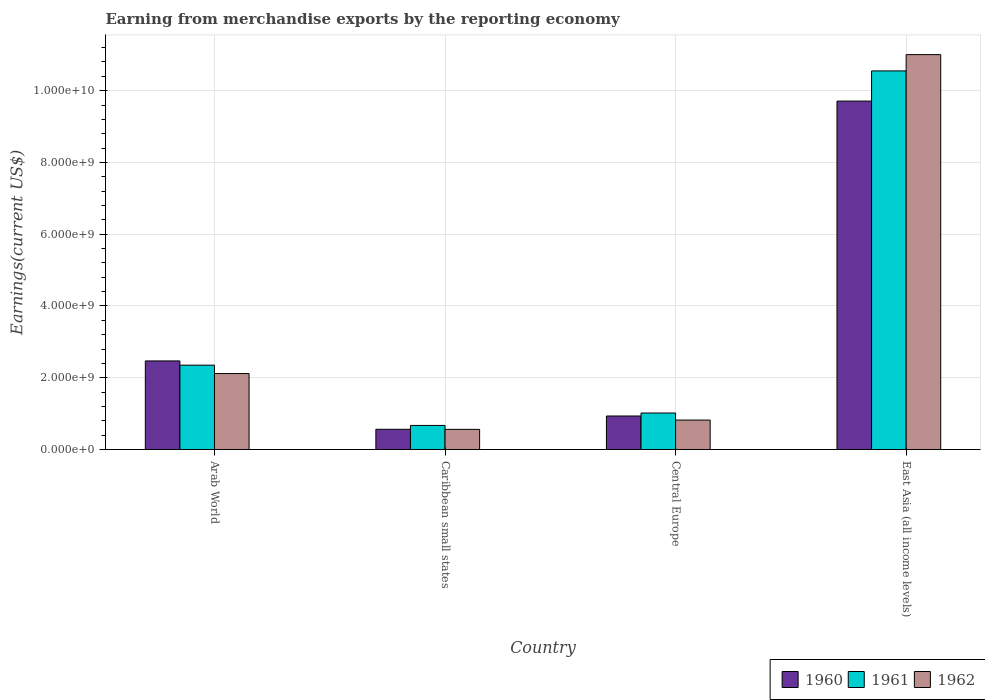How many different coloured bars are there?
Give a very brief answer. 3. How many groups of bars are there?
Provide a short and direct response. 4. Are the number of bars on each tick of the X-axis equal?
Ensure brevity in your answer.  Yes. What is the label of the 2nd group of bars from the left?
Make the answer very short. Caribbean small states. In how many cases, is the number of bars for a given country not equal to the number of legend labels?
Offer a terse response. 0. What is the amount earned from merchandise exports in 1962 in East Asia (all income levels)?
Your answer should be very brief. 1.10e+1. Across all countries, what is the maximum amount earned from merchandise exports in 1961?
Provide a succinct answer. 1.06e+1. Across all countries, what is the minimum amount earned from merchandise exports in 1961?
Offer a terse response. 6.71e+08. In which country was the amount earned from merchandise exports in 1962 maximum?
Your response must be concise. East Asia (all income levels). In which country was the amount earned from merchandise exports in 1960 minimum?
Provide a short and direct response. Caribbean small states. What is the total amount earned from merchandise exports in 1960 in the graph?
Provide a short and direct response. 1.37e+1. What is the difference between the amount earned from merchandise exports in 1962 in Arab World and that in East Asia (all income levels)?
Offer a very short reply. -8.89e+09. What is the difference between the amount earned from merchandise exports in 1962 in Caribbean small states and the amount earned from merchandise exports in 1960 in East Asia (all income levels)?
Your answer should be very brief. -9.15e+09. What is the average amount earned from merchandise exports in 1960 per country?
Provide a short and direct response. 3.42e+09. What is the difference between the amount earned from merchandise exports of/in 1961 and amount earned from merchandise exports of/in 1960 in Arab World?
Your response must be concise. -1.18e+08. What is the ratio of the amount earned from merchandise exports in 1960 in Central Europe to that in East Asia (all income levels)?
Provide a short and direct response. 0.1. Is the amount earned from merchandise exports in 1960 in Caribbean small states less than that in East Asia (all income levels)?
Offer a terse response. Yes. Is the difference between the amount earned from merchandise exports in 1961 in Arab World and Central Europe greater than the difference between the amount earned from merchandise exports in 1960 in Arab World and Central Europe?
Give a very brief answer. No. What is the difference between the highest and the second highest amount earned from merchandise exports in 1962?
Provide a succinct answer. 1.02e+1. What is the difference between the highest and the lowest amount earned from merchandise exports in 1962?
Keep it short and to the point. 1.04e+1. What does the 2nd bar from the left in Caribbean small states represents?
Your answer should be very brief. 1961. What does the 3rd bar from the right in Arab World represents?
Provide a succinct answer. 1960. Is it the case that in every country, the sum of the amount earned from merchandise exports in 1962 and amount earned from merchandise exports in 1961 is greater than the amount earned from merchandise exports in 1960?
Give a very brief answer. Yes. How many bars are there?
Your answer should be compact. 12. Are all the bars in the graph horizontal?
Provide a succinct answer. No. Are the values on the major ticks of Y-axis written in scientific E-notation?
Your answer should be very brief. Yes. Does the graph contain any zero values?
Give a very brief answer. No. Does the graph contain grids?
Ensure brevity in your answer.  Yes. Where does the legend appear in the graph?
Make the answer very short. Bottom right. How many legend labels are there?
Your answer should be very brief. 3. What is the title of the graph?
Make the answer very short. Earning from merchandise exports by the reporting economy. What is the label or title of the Y-axis?
Your response must be concise. Earnings(current US$). What is the Earnings(current US$) of 1960 in Arab World?
Provide a short and direct response. 2.47e+09. What is the Earnings(current US$) in 1961 in Arab World?
Offer a terse response. 2.35e+09. What is the Earnings(current US$) in 1962 in Arab World?
Your answer should be compact. 2.12e+09. What is the Earnings(current US$) in 1960 in Caribbean small states?
Provide a short and direct response. 5.64e+08. What is the Earnings(current US$) of 1961 in Caribbean small states?
Give a very brief answer. 6.71e+08. What is the Earnings(current US$) in 1962 in Caribbean small states?
Offer a very short reply. 5.62e+08. What is the Earnings(current US$) of 1960 in Central Europe?
Keep it short and to the point. 9.34e+08. What is the Earnings(current US$) in 1961 in Central Europe?
Offer a terse response. 1.02e+09. What is the Earnings(current US$) of 1962 in Central Europe?
Your answer should be very brief. 8.21e+08. What is the Earnings(current US$) of 1960 in East Asia (all income levels)?
Give a very brief answer. 9.71e+09. What is the Earnings(current US$) in 1961 in East Asia (all income levels)?
Make the answer very short. 1.06e+1. What is the Earnings(current US$) in 1962 in East Asia (all income levels)?
Keep it short and to the point. 1.10e+1. Across all countries, what is the maximum Earnings(current US$) of 1960?
Offer a terse response. 9.71e+09. Across all countries, what is the maximum Earnings(current US$) in 1961?
Keep it short and to the point. 1.06e+1. Across all countries, what is the maximum Earnings(current US$) in 1962?
Offer a very short reply. 1.10e+1. Across all countries, what is the minimum Earnings(current US$) of 1960?
Ensure brevity in your answer.  5.64e+08. Across all countries, what is the minimum Earnings(current US$) of 1961?
Your answer should be compact. 6.71e+08. Across all countries, what is the minimum Earnings(current US$) of 1962?
Keep it short and to the point. 5.62e+08. What is the total Earnings(current US$) of 1960 in the graph?
Keep it short and to the point. 1.37e+1. What is the total Earnings(current US$) of 1961 in the graph?
Keep it short and to the point. 1.46e+1. What is the total Earnings(current US$) in 1962 in the graph?
Provide a short and direct response. 1.45e+1. What is the difference between the Earnings(current US$) of 1960 in Arab World and that in Caribbean small states?
Provide a succinct answer. 1.90e+09. What is the difference between the Earnings(current US$) of 1961 in Arab World and that in Caribbean small states?
Ensure brevity in your answer.  1.68e+09. What is the difference between the Earnings(current US$) of 1962 in Arab World and that in Caribbean small states?
Ensure brevity in your answer.  1.56e+09. What is the difference between the Earnings(current US$) of 1960 in Arab World and that in Central Europe?
Ensure brevity in your answer.  1.53e+09. What is the difference between the Earnings(current US$) in 1961 in Arab World and that in Central Europe?
Give a very brief answer. 1.33e+09. What is the difference between the Earnings(current US$) of 1962 in Arab World and that in Central Europe?
Your answer should be very brief. 1.30e+09. What is the difference between the Earnings(current US$) of 1960 in Arab World and that in East Asia (all income levels)?
Give a very brief answer. -7.24e+09. What is the difference between the Earnings(current US$) in 1961 in Arab World and that in East Asia (all income levels)?
Offer a terse response. -8.20e+09. What is the difference between the Earnings(current US$) in 1962 in Arab World and that in East Asia (all income levels)?
Ensure brevity in your answer.  -8.89e+09. What is the difference between the Earnings(current US$) in 1960 in Caribbean small states and that in Central Europe?
Provide a succinct answer. -3.70e+08. What is the difference between the Earnings(current US$) in 1961 in Caribbean small states and that in Central Europe?
Your answer should be very brief. -3.46e+08. What is the difference between the Earnings(current US$) in 1962 in Caribbean small states and that in Central Europe?
Provide a short and direct response. -2.60e+08. What is the difference between the Earnings(current US$) in 1960 in Caribbean small states and that in East Asia (all income levels)?
Provide a succinct answer. -9.15e+09. What is the difference between the Earnings(current US$) of 1961 in Caribbean small states and that in East Asia (all income levels)?
Your answer should be very brief. -9.88e+09. What is the difference between the Earnings(current US$) in 1962 in Caribbean small states and that in East Asia (all income levels)?
Ensure brevity in your answer.  -1.04e+1. What is the difference between the Earnings(current US$) in 1960 in Central Europe and that in East Asia (all income levels)?
Provide a succinct answer. -8.78e+09. What is the difference between the Earnings(current US$) in 1961 in Central Europe and that in East Asia (all income levels)?
Keep it short and to the point. -9.53e+09. What is the difference between the Earnings(current US$) in 1962 in Central Europe and that in East Asia (all income levels)?
Provide a succinct answer. -1.02e+1. What is the difference between the Earnings(current US$) of 1960 in Arab World and the Earnings(current US$) of 1961 in Caribbean small states?
Offer a terse response. 1.80e+09. What is the difference between the Earnings(current US$) in 1960 in Arab World and the Earnings(current US$) in 1962 in Caribbean small states?
Provide a short and direct response. 1.91e+09. What is the difference between the Earnings(current US$) in 1961 in Arab World and the Earnings(current US$) in 1962 in Caribbean small states?
Your answer should be compact. 1.79e+09. What is the difference between the Earnings(current US$) in 1960 in Arab World and the Earnings(current US$) in 1961 in Central Europe?
Keep it short and to the point. 1.45e+09. What is the difference between the Earnings(current US$) of 1960 in Arab World and the Earnings(current US$) of 1962 in Central Europe?
Offer a terse response. 1.65e+09. What is the difference between the Earnings(current US$) in 1961 in Arab World and the Earnings(current US$) in 1962 in Central Europe?
Keep it short and to the point. 1.53e+09. What is the difference between the Earnings(current US$) in 1960 in Arab World and the Earnings(current US$) in 1961 in East Asia (all income levels)?
Provide a short and direct response. -8.08e+09. What is the difference between the Earnings(current US$) in 1960 in Arab World and the Earnings(current US$) in 1962 in East Asia (all income levels)?
Your response must be concise. -8.54e+09. What is the difference between the Earnings(current US$) of 1961 in Arab World and the Earnings(current US$) of 1962 in East Asia (all income levels)?
Your answer should be very brief. -8.65e+09. What is the difference between the Earnings(current US$) of 1960 in Caribbean small states and the Earnings(current US$) of 1961 in Central Europe?
Provide a short and direct response. -4.53e+08. What is the difference between the Earnings(current US$) in 1960 in Caribbean small states and the Earnings(current US$) in 1962 in Central Europe?
Give a very brief answer. -2.57e+08. What is the difference between the Earnings(current US$) of 1961 in Caribbean small states and the Earnings(current US$) of 1962 in Central Europe?
Give a very brief answer. -1.50e+08. What is the difference between the Earnings(current US$) of 1960 in Caribbean small states and the Earnings(current US$) of 1961 in East Asia (all income levels)?
Your answer should be compact. -9.99e+09. What is the difference between the Earnings(current US$) in 1960 in Caribbean small states and the Earnings(current US$) in 1962 in East Asia (all income levels)?
Your answer should be compact. -1.04e+1. What is the difference between the Earnings(current US$) of 1961 in Caribbean small states and the Earnings(current US$) of 1962 in East Asia (all income levels)?
Provide a short and direct response. -1.03e+1. What is the difference between the Earnings(current US$) in 1960 in Central Europe and the Earnings(current US$) in 1961 in East Asia (all income levels)?
Provide a short and direct response. -9.62e+09. What is the difference between the Earnings(current US$) in 1960 in Central Europe and the Earnings(current US$) in 1962 in East Asia (all income levels)?
Offer a terse response. -1.01e+1. What is the difference between the Earnings(current US$) in 1961 in Central Europe and the Earnings(current US$) in 1962 in East Asia (all income levels)?
Offer a very short reply. -9.99e+09. What is the average Earnings(current US$) of 1960 per country?
Provide a short and direct response. 3.42e+09. What is the average Earnings(current US$) of 1961 per country?
Make the answer very short. 3.65e+09. What is the average Earnings(current US$) of 1962 per country?
Make the answer very short. 3.63e+09. What is the difference between the Earnings(current US$) in 1960 and Earnings(current US$) in 1961 in Arab World?
Offer a very short reply. 1.18e+08. What is the difference between the Earnings(current US$) of 1960 and Earnings(current US$) of 1962 in Arab World?
Your answer should be compact. 3.52e+08. What is the difference between the Earnings(current US$) in 1961 and Earnings(current US$) in 1962 in Arab World?
Your answer should be compact. 2.34e+08. What is the difference between the Earnings(current US$) in 1960 and Earnings(current US$) in 1961 in Caribbean small states?
Keep it short and to the point. -1.07e+08. What is the difference between the Earnings(current US$) in 1960 and Earnings(current US$) in 1962 in Caribbean small states?
Your answer should be very brief. 2.40e+06. What is the difference between the Earnings(current US$) of 1961 and Earnings(current US$) of 1962 in Caribbean small states?
Provide a short and direct response. 1.10e+08. What is the difference between the Earnings(current US$) in 1960 and Earnings(current US$) in 1961 in Central Europe?
Keep it short and to the point. -8.30e+07. What is the difference between the Earnings(current US$) in 1960 and Earnings(current US$) in 1962 in Central Europe?
Provide a short and direct response. 1.13e+08. What is the difference between the Earnings(current US$) in 1961 and Earnings(current US$) in 1962 in Central Europe?
Keep it short and to the point. 1.96e+08. What is the difference between the Earnings(current US$) of 1960 and Earnings(current US$) of 1961 in East Asia (all income levels)?
Give a very brief answer. -8.41e+08. What is the difference between the Earnings(current US$) of 1960 and Earnings(current US$) of 1962 in East Asia (all income levels)?
Provide a short and direct response. -1.29e+09. What is the difference between the Earnings(current US$) of 1961 and Earnings(current US$) of 1962 in East Asia (all income levels)?
Your answer should be very brief. -4.54e+08. What is the ratio of the Earnings(current US$) in 1960 in Arab World to that in Caribbean small states?
Your response must be concise. 4.38. What is the ratio of the Earnings(current US$) in 1961 in Arab World to that in Caribbean small states?
Your answer should be very brief. 3.5. What is the ratio of the Earnings(current US$) in 1962 in Arab World to that in Caribbean small states?
Make the answer very short. 3.77. What is the ratio of the Earnings(current US$) in 1960 in Arab World to that in Central Europe?
Offer a very short reply. 2.64. What is the ratio of the Earnings(current US$) in 1961 in Arab World to that in Central Europe?
Your answer should be very brief. 2.31. What is the ratio of the Earnings(current US$) of 1962 in Arab World to that in Central Europe?
Offer a terse response. 2.58. What is the ratio of the Earnings(current US$) in 1960 in Arab World to that in East Asia (all income levels)?
Make the answer very short. 0.25. What is the ratio of the Earnings(current US$) in 1961 in Arab World to that in East Asia (all income levels)?
Offer a terse response. 0.22. What is the ratio of the Earnings(current US$) of 1962 in Arab World to that in East Asia (all income levels)?
Your answer should be compact. 0.19. What is the ratio of the Earnings(current US$) of 1960 in Caribbean small states to that in Central Europe?
Offer a very short reply. 0.6. What is the ratio of the Earnings(current US$) of 1961 in Caribbean small states to that in Central Europe?
Make the answer very short. 0.66. What is the ratio of the Earnings(current US$) of 1962 in Caribbean small states to that in Central Europe?
Offer a very short reply. 0.68. What is the ratio of the Earnings(current US$) in 1960 in Caribbean small states to that in East Asia (all income levels)?
Provide a succinct answer. 0.06. What is the ratio of the Earnings(current US$) of 1961 in Caribbean small states to that in East Asia (all income levels)?
Provide a short and direct response. 0.06. What is the ratio of the Earnings(current US$) in 1962 in Caribbean small states to that in East Asia (all income levels)?
Provide a short and direct response. 0.05. What is the ratio of the Earnings(current US$) in 1960 in Central Europe to that in East Asia (all income levels)?
Keep it short and to the point. 0.1. What is the ratio of the Earnings(current US$) of 1961 in Central Europe to that in East Asia (all income levels)?
Make the answer very short. 0.1. What is the ratio of the Earnings(current US$) in 1962 in Central Europe to that in East Asia (all income levels)?
Offer a very short reply. 0.07. What is the difference between the highest and the second highest Earnings(current US$) of 1960?
Your answer should be compact. 7.24e+09. What is the difference between the highest and the second highest Earnings(current US$) in 1961?
Provide a succinct answer. 8.20e+09. What is the difference between the highest and the second highest Earnings(current US$) of 1962?
Your response must be concise. 8.89e+09. What is the difference between the highest and the lowest Earnings(current US$) of 1960?
Provide a succinct answer. 9.15e+09. What is the difference between the highest and the lowest Earnings(current US$) of 1961?
Provide a succinct answer. 9.88e+09. What is the difference between the highest and the lowest Earnings(current US$) in 1962?
Provide a short and direct response. 1.04e+1. 